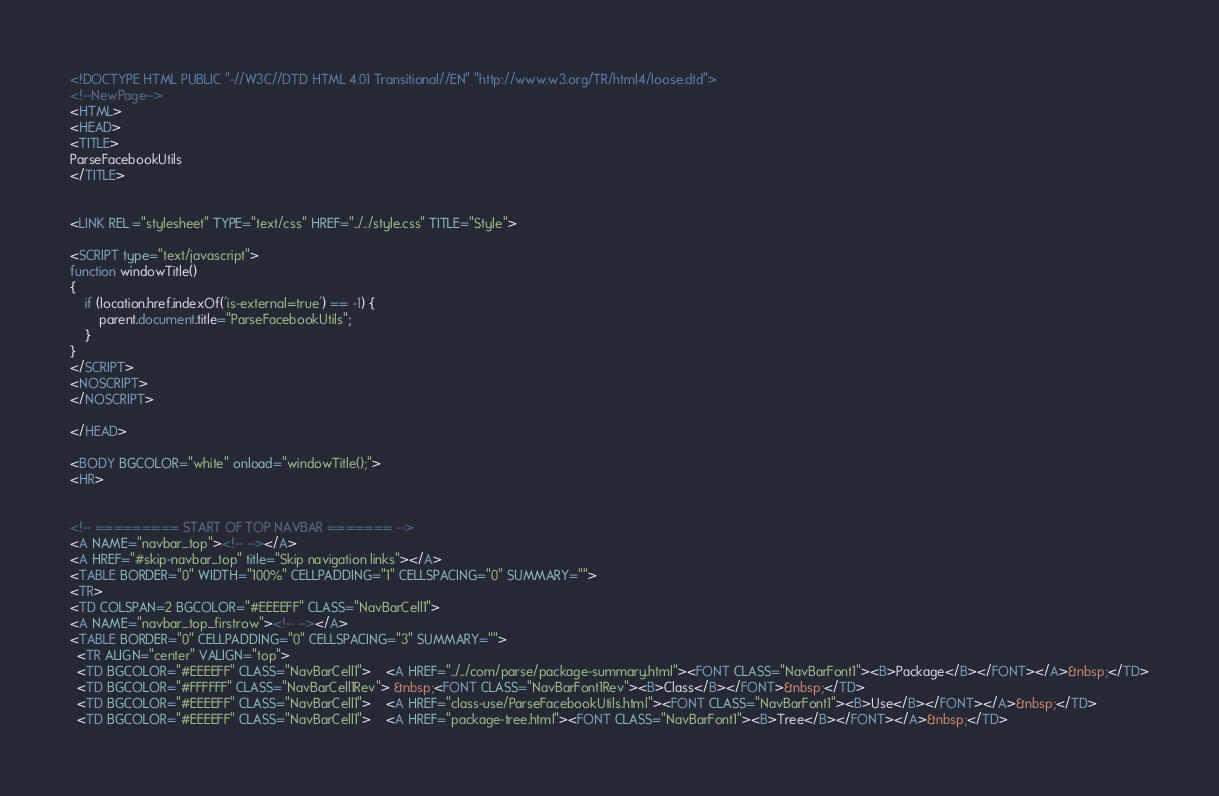Convert code to text. <code><loc_0><loc_0><loc_500><loc_500><_HTML_><!DOCTYPE HTML PUBLIC "-//W3C//DTD HTML 4.01 Transitional//EN" "http://www.w3.org/TR/html4/loose.dtd">
<!--NewPage-->
<HTML>
<HEAD>
<TITLE>
ParseFacebookUtils
</TITLE>


<LINK REL ="stylesheet" TYPE="text/css" HREF="../../style.css" TITLE="Style">

<SCRIPT type="text/javascript">
function windowTitle()
{
    if (location.href.indexOf('is-external=true') == -1) {
        parent.document.title="ParseFacebookUtils";
    }
}
</SCRIPT>
<NOSCRIPT>
</NOSCRIPT>

</HEAD>

<BODY BGCOLOR="white" onload="windowTitle();">
<HR>


<!-- ========= START OF TOP NAVBAR ======= -->
<A NAME="navbar_top"><!-- --></A>
<A HREF="#skip-navbar_top" title="Skip navigation links"></A>
<TABLE BORDER="0" WIDTH="100%" CELLPADDING="1" CELLSPACING="0" SUMMARY="">
<TR>
<TD COLSPAN=2 BGCOLOR="#EEEEFF" CLASS="NavBarCell1">
<A NAME="navbar_top_firstrow"><!-- --></A>
<TABLE BORDER="0" CELLPADDING="0" CELLSPACING="3" SUMMARY="">
  <TR ALIGN="center" VALIGN="top">
  <TD BGCOLOR="#EEEEFF" CLASS="NavBarCell1">    <A HREF="../../com/parse/package-summary.html"><FONT CLASS="NavBarFont1"><B>Package</B></FONT></A>&nbsp;</TD>
  <TD BGCOLOR="#FFFFFF" CLASS="NavBarCell1Rev"> &nbsp;<FONT CLASS="NavBarFont1Rev"><B>Class</B></FONT>&nbsp;</TD>
  <TD BGCOLOR="#EEEEFF" CLASS="NavBarCell1">    <A HREF="class-use/ParseFacebookUtils.html"><FONT CLASS="NavBarFont1"><B>Use</B></FONT></A>&nbsp;</TD>
  <TD BGCOLOR="#EEEEFF" CLASS="NavBarCell1">    <A HREF="package-tree.html"><FONT CLASS="NavBarFont1"><B>Tree</B></FONT></A>&nbsp;</TD></code> 